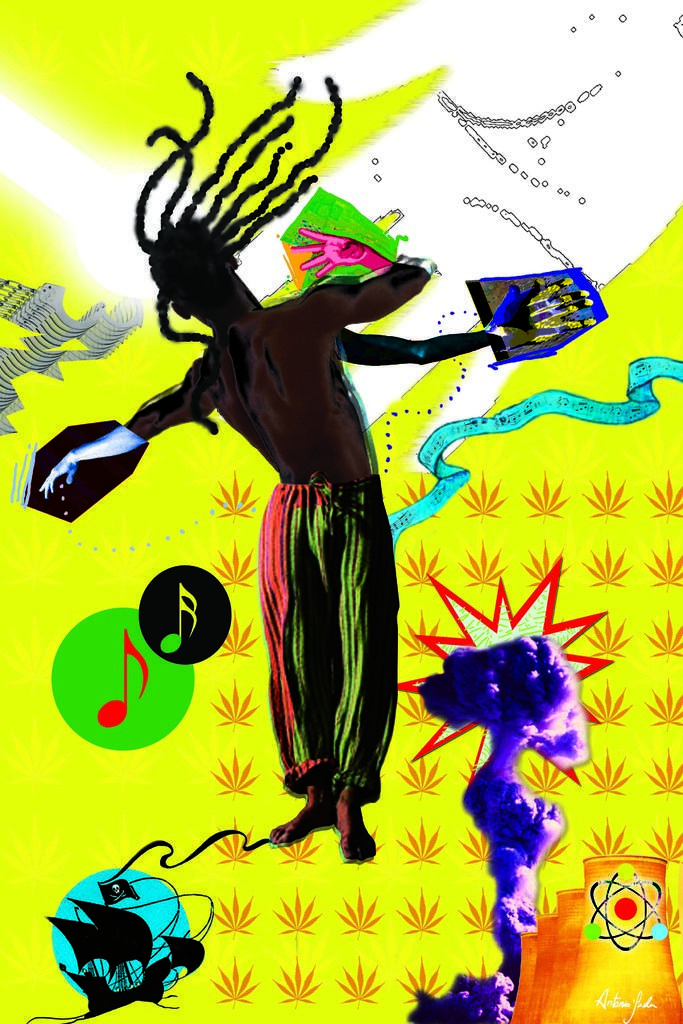How would you summarize this image in a sentence or two? This image is a painting. In this image we can see a person and kites. 